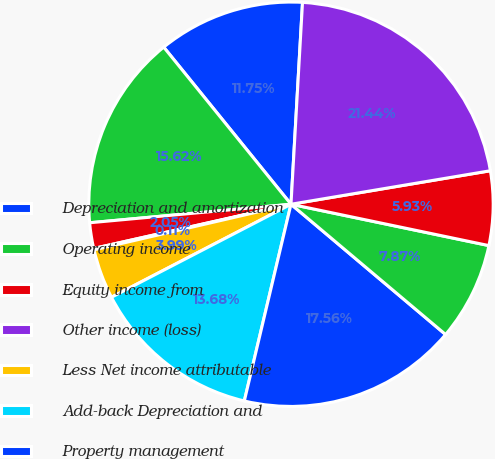Convert chart to OTSL. <chart><loc_0><loc_0><loc_500><loc_500><pie_chart><fcel>Depreciation and amortization<fcel>Operating income<fcel>Equity income from<fcel>Other income (loss)<fcel>Less Net income attributable<fcel>Add-back Depreciation and<fcel>Property management<fcel>Leasing<fcel>Sales<fcel>Development services<nl><fcel>11.75%<fcel>15.63%<fcel>2.05%<fcel>0.11%<fcel>3.99%<fcel>13.69%<fcel>17.57%<fcel>7.87%<fcel>5.93%<fcel>21.45%<nl></chart> 